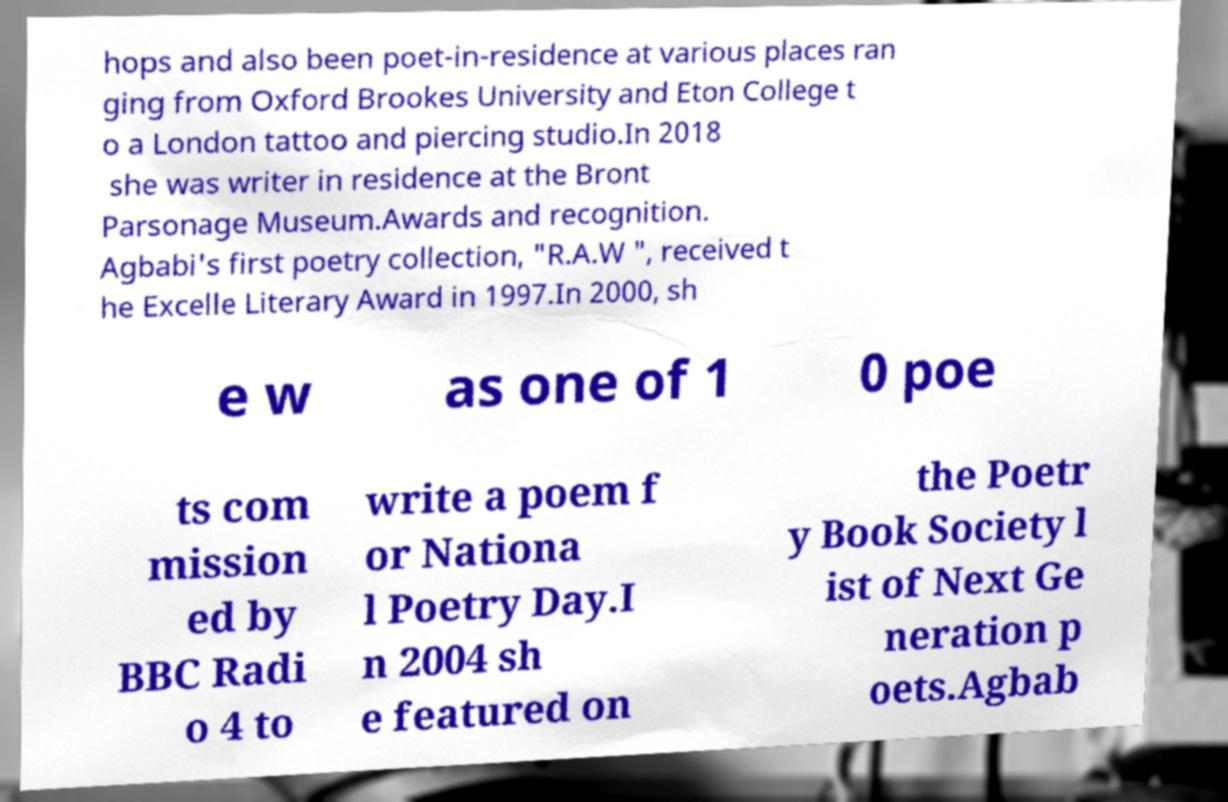There's text embedded in this image that I need extracted. Can you transcribe it verbatim? hops and also been poet-in-residence at various places ran ging from Oxford Brookes University and Eton College t o a London tattoo and piercing studio.In 2018 she was writer in residence at the Bront Parsonage Museum.Awards and recognition. Agbabi's first poetry collection, "R.A.W ", received t he Excelle Literary Award in 1997.In 2000, sh e w as one of 1 0 poe ts com mission ed by BBC Radi o 4 to write a poem f or Nationa l Poetry Day.I n 2004 sh e featured on the Poetr y Book Society l ist of Next Ge neration p oets.Agbab 